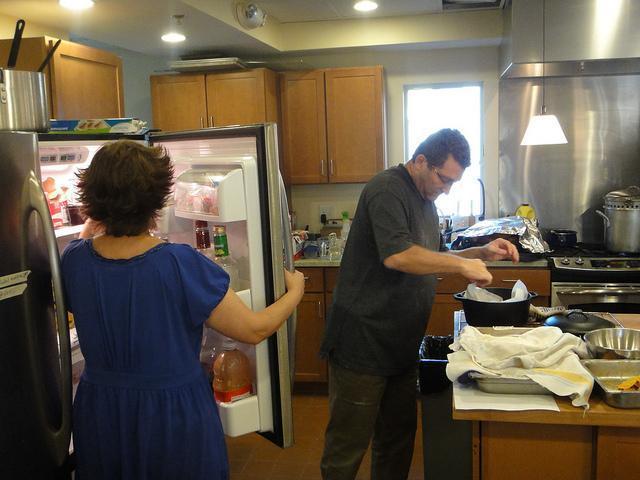How many refrigerators are there?
Give a very brief answer. 1. How many people are in the photo?
Give a very brief answer. 2. 